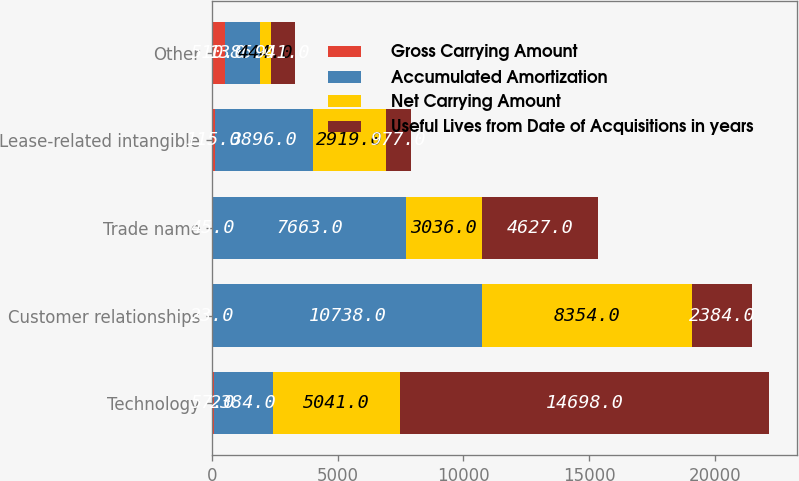Convert chart to OTSL. <chart><loc_0><loc_0><loc_500><loc_500><stacked_bar_chart><ecel><fcel>Technology<fcel>Customer relationships<fcel>Trade name<fcel>Lease-related intangible<fcel>Other<nl><fcel>Gross Carrying Amount<fcel>57<fcel>23<fcel>45<fcel>115<fcel>510<nl><fcel>Accumulated Amortization<fcel>2384<fcel>10738<fcel>7663<fcel>3896<fcel>1385<nl><fcel>Net Carrying Amount<fcel>5041<fcel>8354<fcel>3036<fcel>2919<fcel>444<nl><fcel>Useful Lives from Date of Acquisitions in years<fcel>14698<fcel>2384<fcel>4627<fcel>977<fcel>941<nl></chart> 